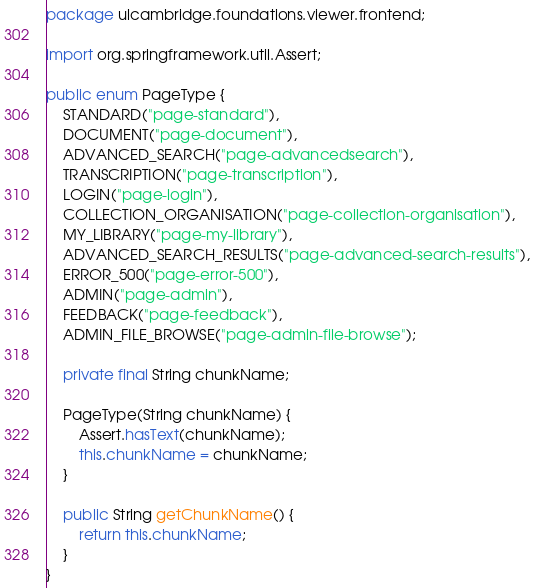Convert code to text. <code><loc_0><loc_0><loc_500><loc_500><_Java_>package ulcambridge.foundations.viewer.frontend;

import org.springframework.util.Assert;

public enum PageType {
    STANDARD("page-standard"),
    DOCUMENT("page-document"),
    ADVANCED_SEARCH("page-advancedsearch"),
    TRANSCRIPTION("page-transcription"),
    LOGIN("page-login"),
    COLLECTION_ORGANISATION("page-collection-organisation"),
    MY_LIBRARY("page-my-library"),
    ADVANCED_SEARCH_RESULTS("page-advanced-search-results"),
    ERROR_500("page-error-500"),
    ADMIN("page-admin"),
    FEEDBACK("page-feedback"),
    ADMIN_FILE_BROWSE("page-admin-file-browse");

    private final String chunkName;

    PageType(String chunkName) {
        Assert.hasText(chunkName);
        this.chunkName = chunkName;
    }

    public String getChunkName() {
        return this.chunkName;
    }
}
</code> 